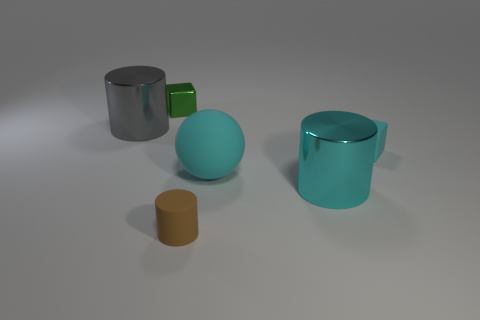Do the thing in front of the big cyan metallic cylinder and the tiny cyan block have the same material?
Your answer should be compact. Yes. Are the big cyan thing that is behind the cyan metallic thing and the large object to the left of the tiny brown object made of the same material?
Your answer should be compact. No. Is the number of rubber objects in front of the rubber sphere greater than the number of big brown things?
Your response must be concise. Yes. The block that is on the left side of the metallic cylinder that is on the right side of the big cyan ball is what color?
Your response must be concise. Green. What is the shape of the green shiny thing that is the same size as the matte cube?
Make the answer very short. Cube. There is a big shiny object that is the same color as the big ball; what shape is it?
Your answer should be very brief. Cylinder. Are there the same number of brown things left of the rubber cylinder and large red blocks?
Ensure brevity in your answer.  Yes. What is the tiny block behind the big gray metallic thing on the left side of the small matte object left of the large cyan metallic cylinder made of?
Make the answer very short. Metal. What is the shape of the small cyan thing that is made of the same material as the tiny brown thing?
Your answer should be very brief. Cube. Is there any other thing that has the same color as the small cylinder?
Ensure brevity in your answer.  No. 